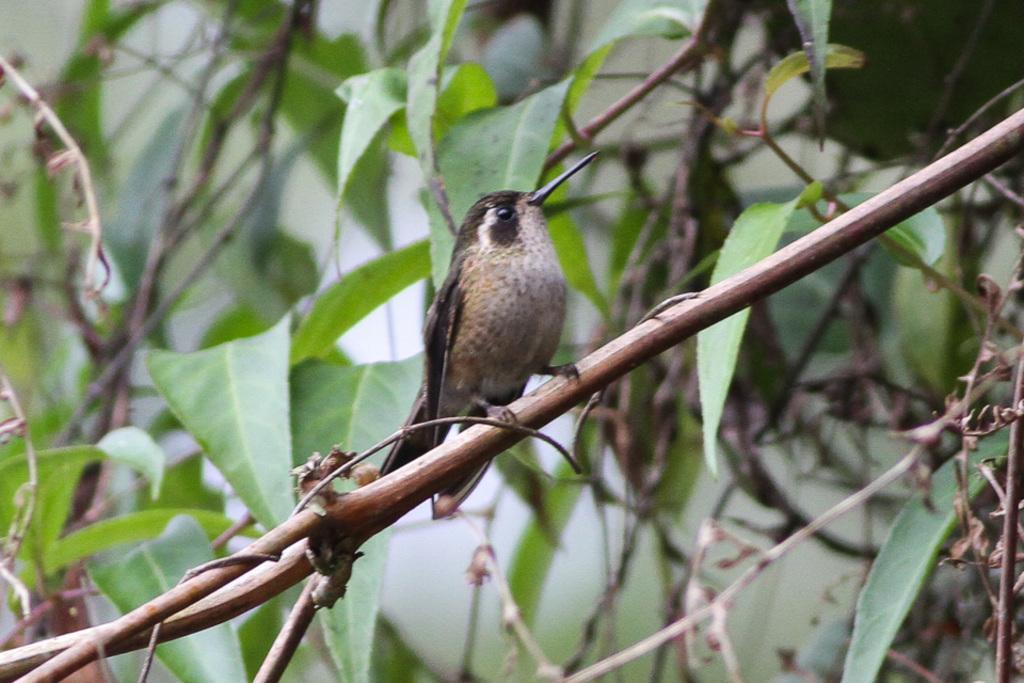Describe this image in one or two sentences. In this image I can see a bird. It is brown and white color. The bird is on the thin branch. Back I can see green leaves. 